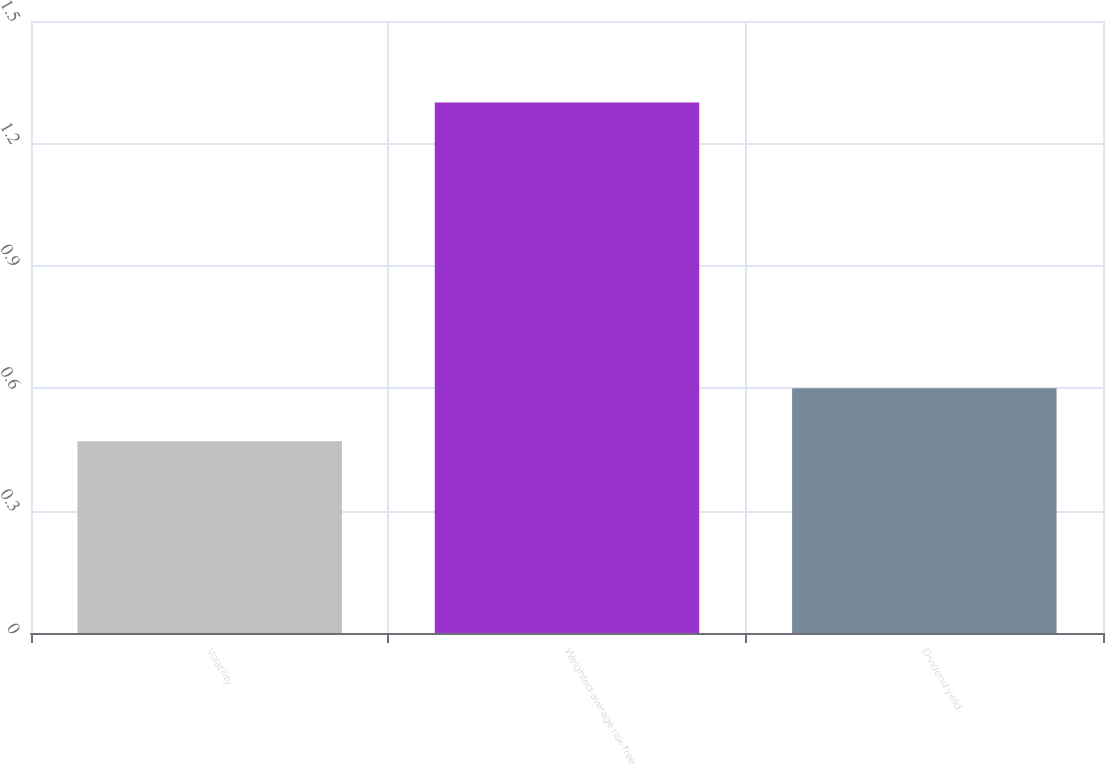Convert chart to OTSL. <chart><loc_0><loc_0><loc_500><loc_500><bar_chart><fcel>Volatility<fcel>Weighted-average risk-free<fcel>Dividend yield<nl><fcel>0.47<fcel>1.3<fcel>0.6<nl></chart> 